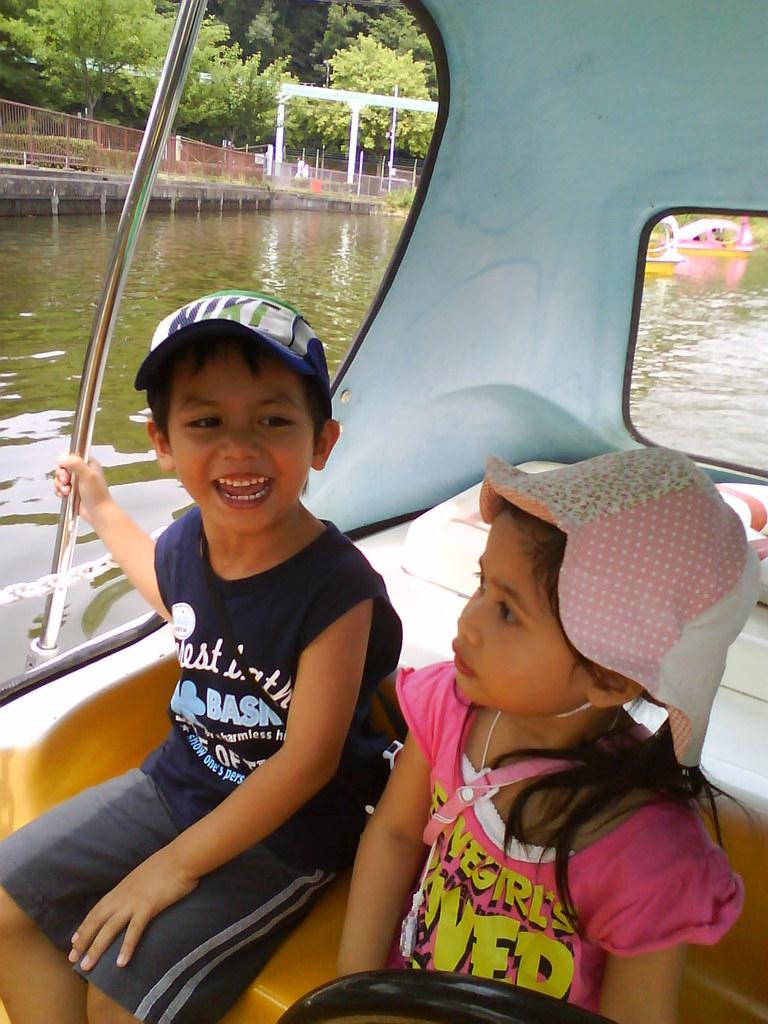How many kids are in the image? There are kids in the image, but the exact number is not specified. What are the kids doing in the image? The kids are sitting in a boat in the image. What is the boy holding in the image? The boy is holding a rod in the image. What can be seen in the background of the image? In the background of the image, there is water, railing, a bridge, poles, trees, and other unspecified things. What type of snails can be seen crawling on the health of the kids in the image? There are no snails present in the image, and the health of the kids is not mentioned or visible. What type of battle is taking place in the background of the image? There is no battle present in the image; it features kids sitting in a boat with a boy holding a rod, surrounded by various background elements. 